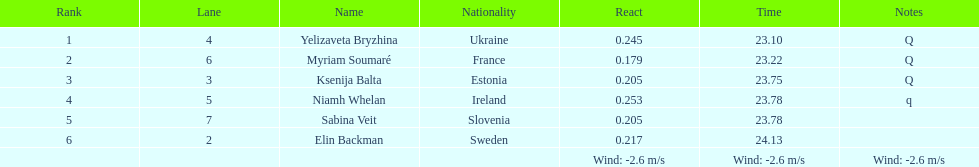Name of athlete who came in first in heat 1 of the women's 200 metres Yelizaveta Bryzhina. 